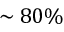<formula> <loc_0><loc_0><loc_500><loc_500>\sim 8 0 \%</formula> 